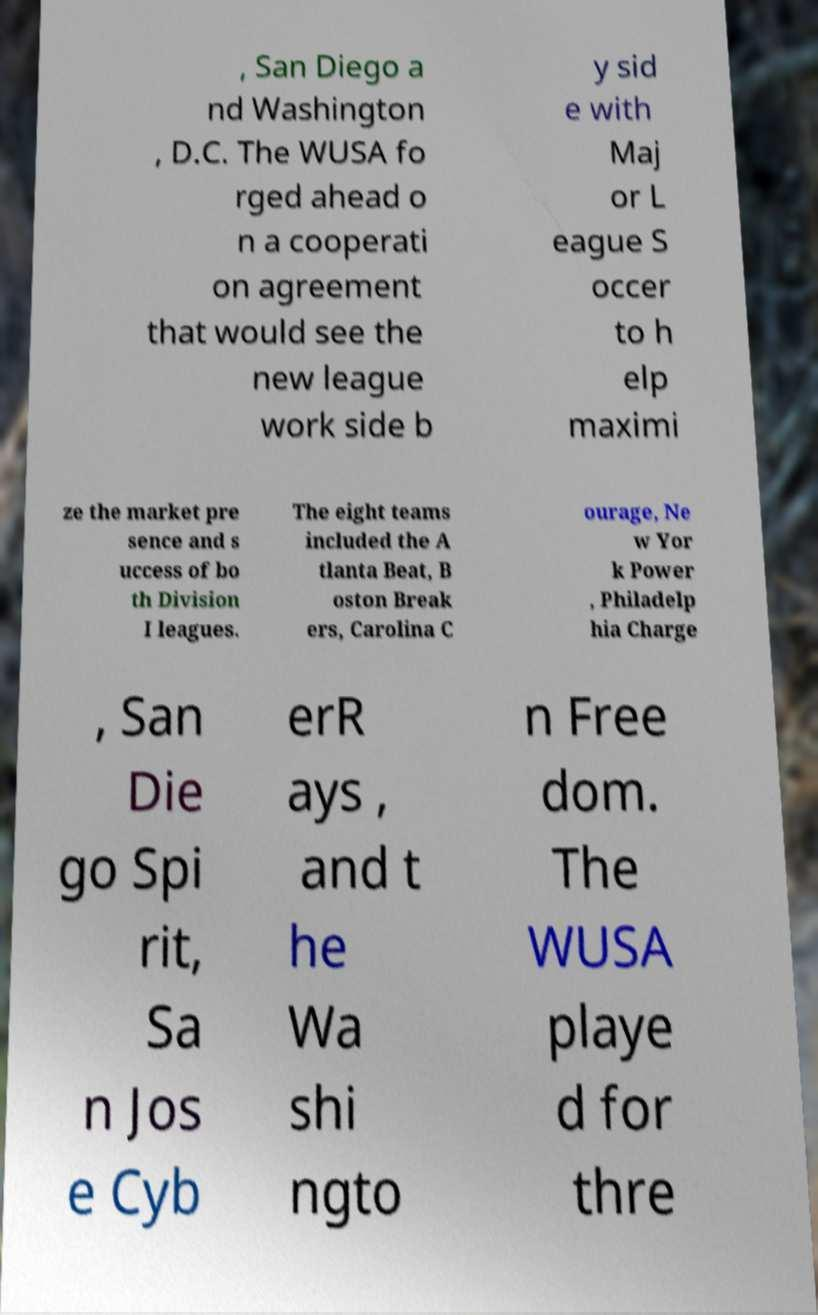For documentation purposes, I need the text within this image transcribed. Could you provide that? , San Diego a nd Washington , D.C. The WUSA fo rged ahead o n a cooperati on agreement that would see the new league work side b y sid e with Maj or L eague S occer to h elp maximi ze the market pre sence and s uccess of bo th Division I leagues. The eight teams included the A tlanta Beat, B oston Break ers, Carolina C ourage, Ne w Yor k Power , Philadelp hia Charge , San Die go Spi rit, Sa n Jos e Cyb erR ays , and t he Wa shi ngto n Free dom. The WUSA playe d for thre 